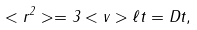Convert formula to latex. <formula><loc_0><loc_0><loc_500><loc_500>< r ^ { 2 } > = 3 < v > \ell t = D t ,</formula> 